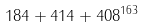Convert formula to latex. <formula><loc_0><loc_0><loc_500><loc_500>1 8 4 + 4 1 4 + 4 0 8 ^ { 1 6 3 }</formula> 